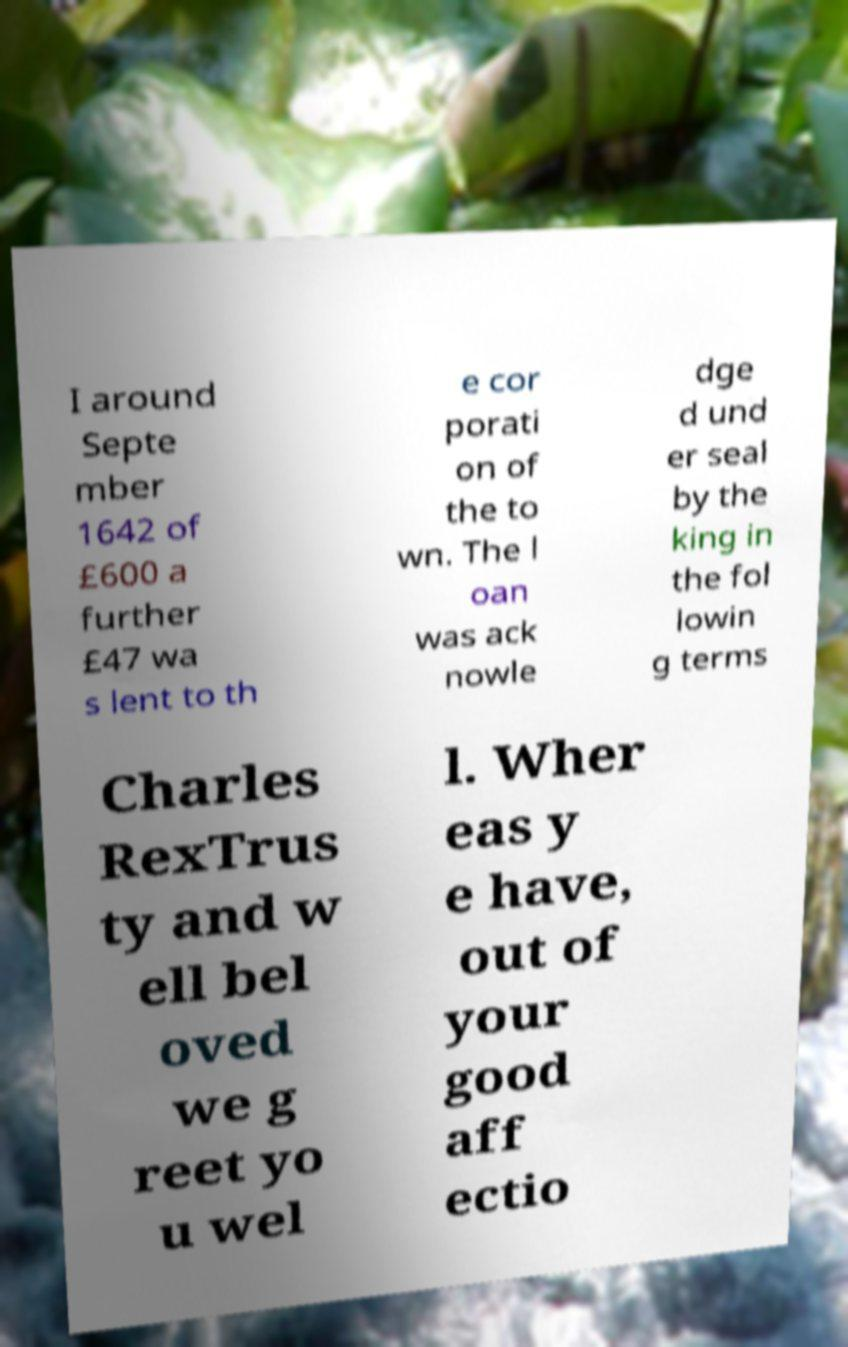For documentation purposes, I need the text within this image transcribed. Could you provide that? I around Septe mber 1642 of £600 a further £47 wa s lent to th e cor porati on of the to wn. The l oan was ack nowle dge d und er seal by the king in the fol lowin g terms Charles RexTrus ty and w ell bel oved we g reet yo u wel l. Wher eas y e have, out of your good aff ectio 